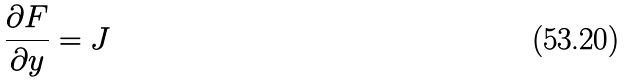<formula> <loc_0><loc_0><loc_500><loc_500>\frac { \partial F } { \partial y } = J</formula> 